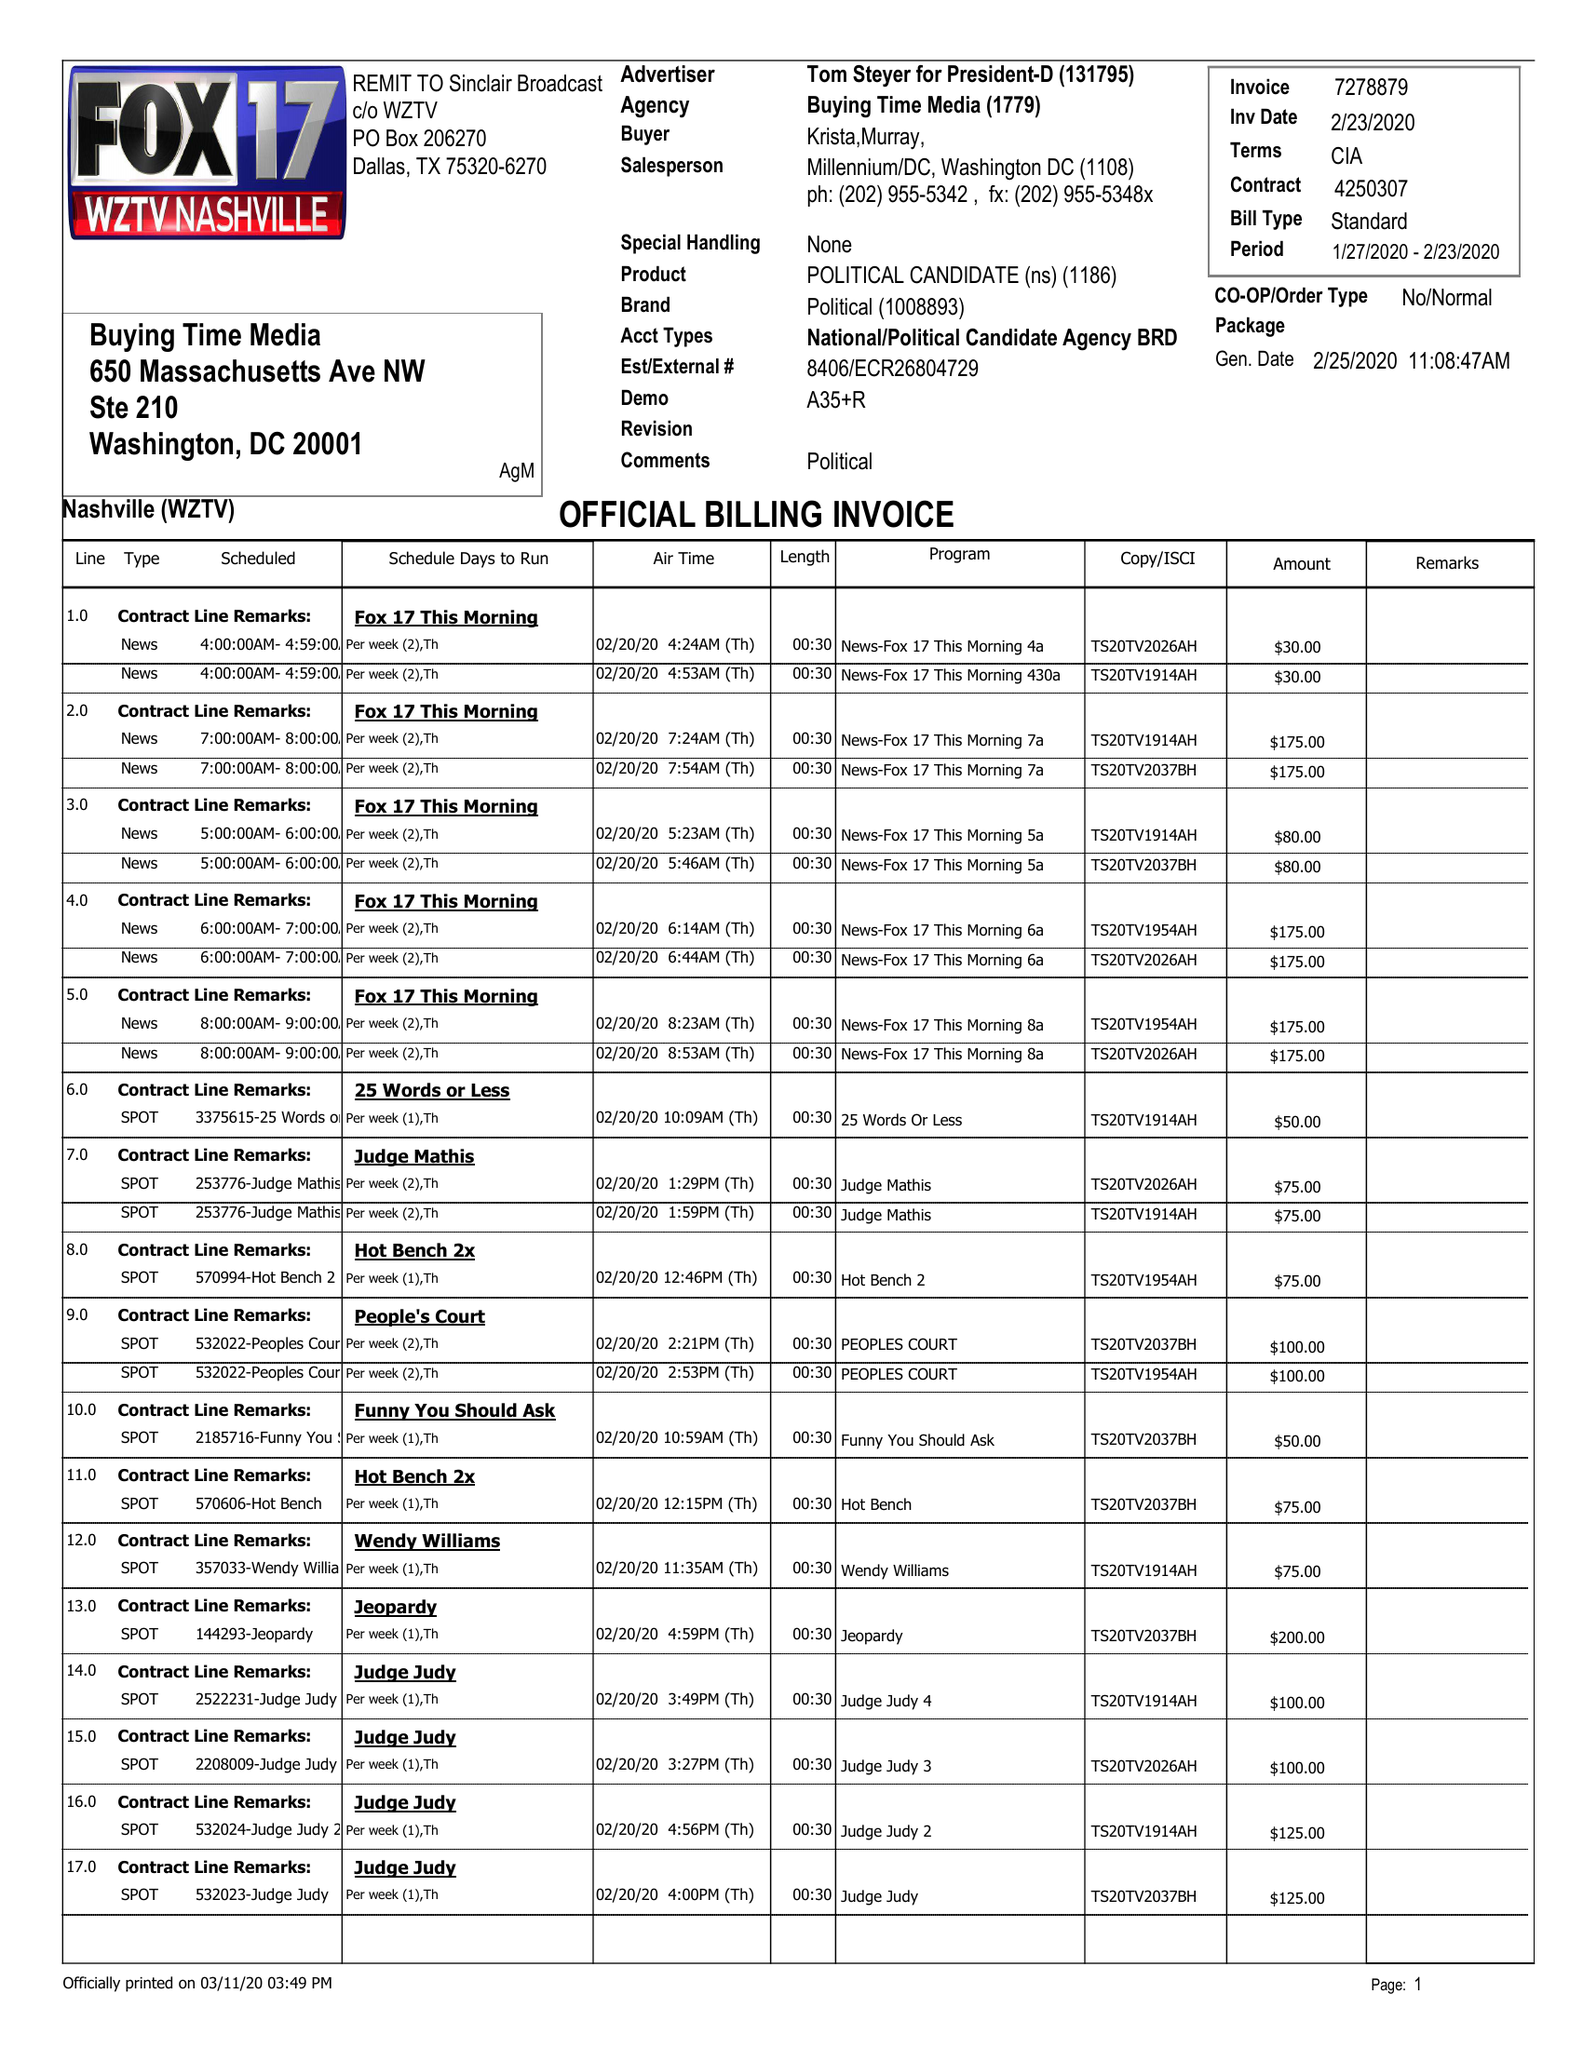What is the value for the flight_from?
Answer the question using a single word or phrase. 01/27/20 